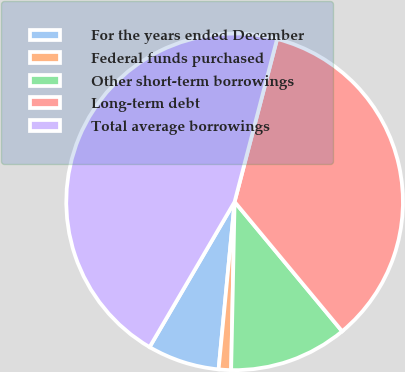Convert chart. <chart><loc_0><loc_0><loc_500><loc_500><pie_chart><fcel>For the years ended December<fcel>Federal funds purchased<fcel>Other short-term borrowings<fcel>Long-term debt<fcel>Total average borrowings<nl><fcel>6.91%<fcel>1.19%<fcel>11.36%<fcel>34.91%<fcel>45.64%<nl></chart> 